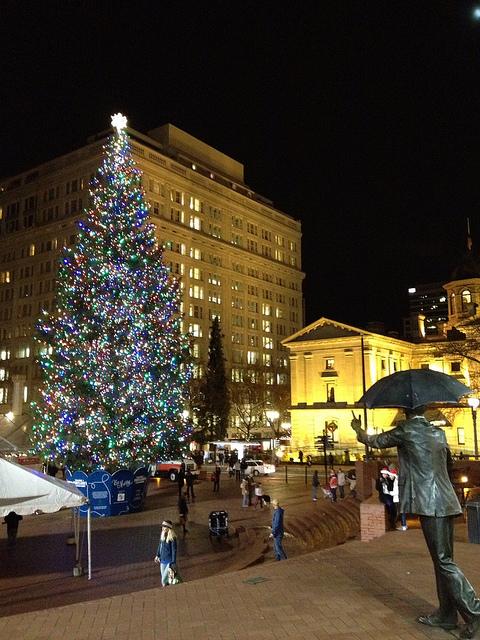What is the statue holding?
Give a very brief answer. Umbrella. Is it Christmas?
Keep it brief. Yes. How many buildings are visible in this picture?
Quick response, please. 2. If three people die in this photo how many are still alive?
Be succinct. 12. 